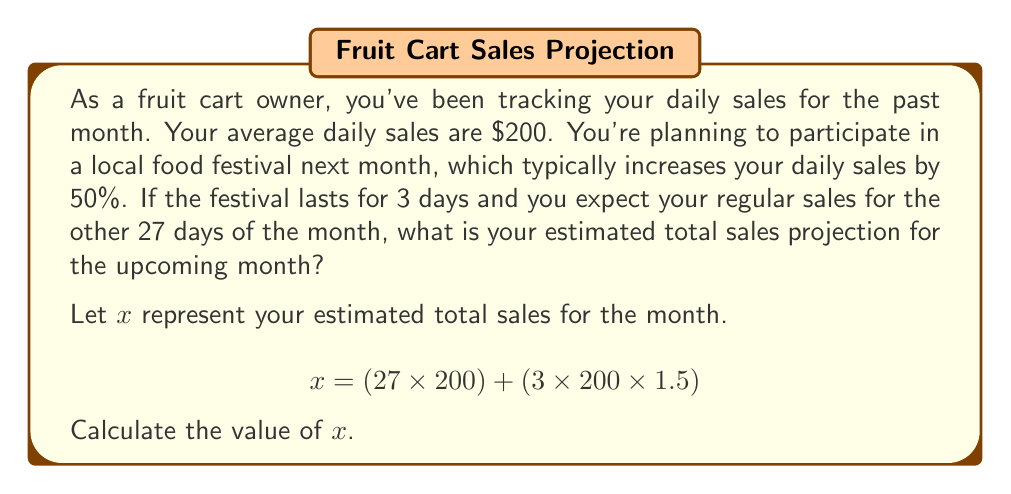Can you answer this question? To solve this problem, we'll break it down into steps:

1. Calculate regular sales for 27 days:
   $$27 \times \$200 = \$5,400$$

2. Calculate sales for the 3 festival days:
   - Regular daily sales: $200
   - Increase during festival: 50% or 0.5
   - Sales during festival days: $200 \times 1.5 = \$300$ per day
   - Total for 3 festival days: $3 \times \$300 = \$900$

3. Sum up the total sales for the month:
   $$x = \$5,400 + \$900 = \$6,300$$

Therefore, the estimated total sales projection for the upcoming month is $6,300.
Answer: $6,300 